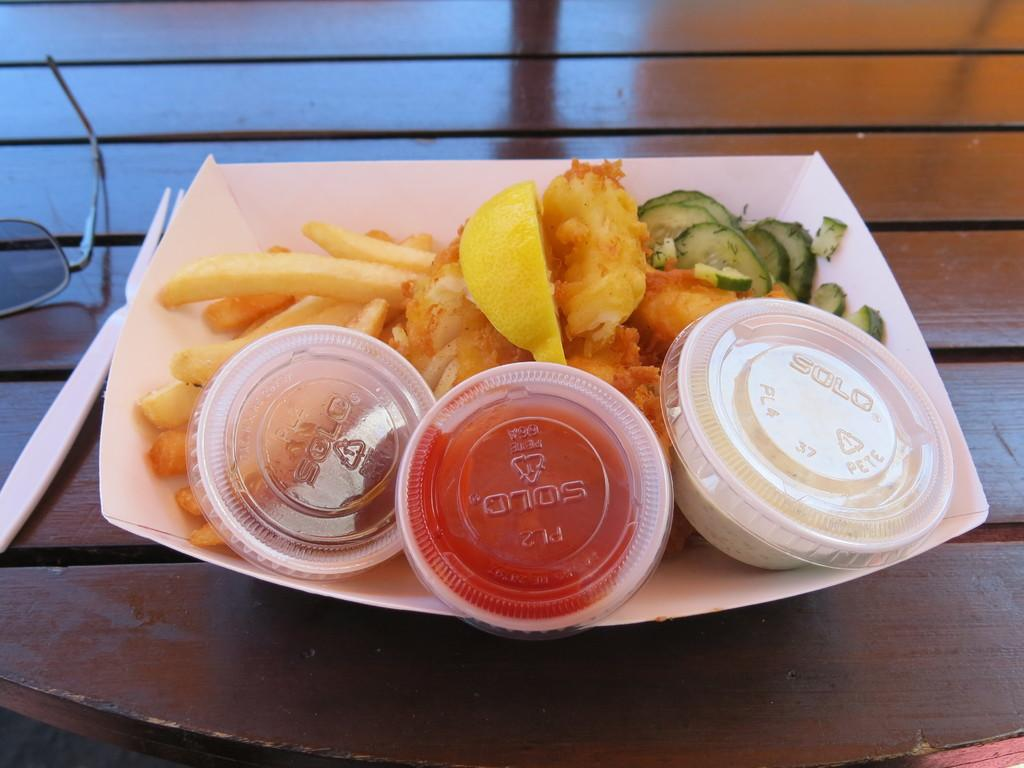What piece of furniture is visible in the image? There is a table in the image. What is placed on the table? There is a plate, a fork, spectacles, and three cups on the table. What type of food is present in the image? French fries are present in the image. What is on the plate? There is food in the plate. Can you see a squirrel holding a match in the image? There is no squirrel or match present in the image. What place is depicted in the image? The image does not show a specific place; it only shows a table with various objects on it. 